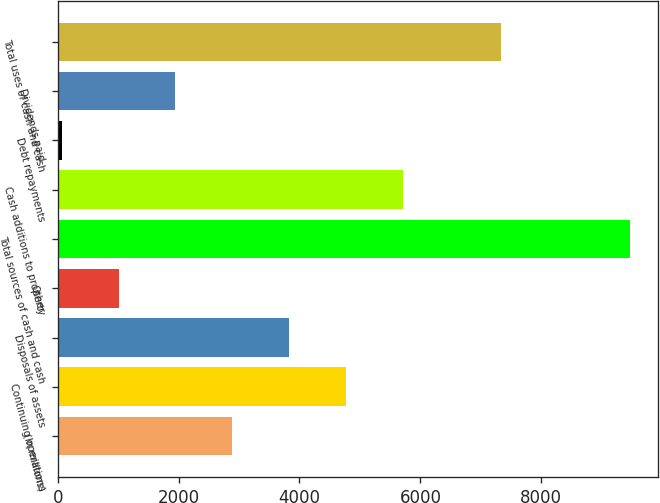Convert chart. <chart><loc_0><loc_0><loc_500><loc_500><bar_chart><fcel>(In millions)<fcel>Continuing operations<fcel>Disposals of assets<fcel>Other<fcel>Total sources of cash and cash<fcel>Cash additions to property<fcel>Debt repayments<fcel>Dividends paid<fcel>Total uses of cash and cash<nl><fcel>2885.9<fcel>4764.5<fcel>3825.2<fcel>1007.3<fcel>9461<fcel>5703.8<fcel>68<fcel>1946.6<fcel>7327<nl></chart> 